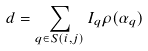Convert formula to latex. <formula><loc_0><loc_0><loc_500><loc_500>d = \sum _ { q \in S ( i , j ) } I _ { q } \rho ( \alpha _ { q } )</formula> 